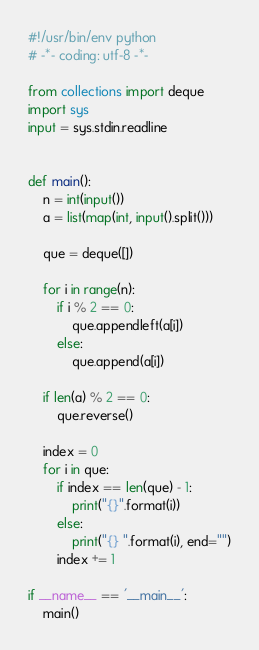Convert code to text. <code><loc_0><loc_0><loc_500><loc_500><_Python_>#!/usr/bin/env python
# -*- coding: utf-8 -*-

from collections import deque
import sys
input = sys.stdin.readline


def main():
    n = int(input())
    a = list(map(int, input().split()))

    que = deque([])

    for i in range(n):
        if i % 2 == 0:
            que.appendleft(a[i])
        else:
            que.append(a[i])

    if len(a) % 2 == 0:
        que.reverse()

    index = 0
    for i in que:
        if index == len(que) - 1:
            print("{}".format(i))
        else:
            print("{} ".format(i), end="")
        index += 1

if __name__ == '__main__':
    main()
</code> 